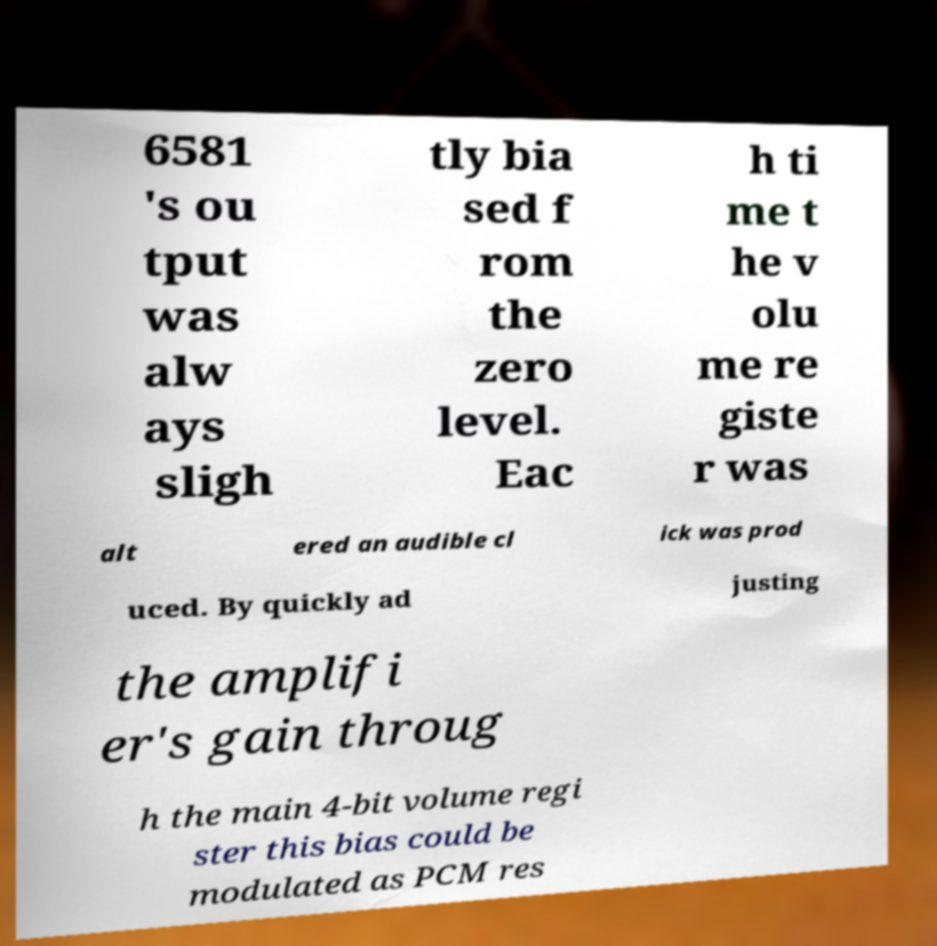I need the written content from this picture converted into text. Can you do that? 6581 's ou tput was alw ays sligh tly bia sed f rom the zero level. Eac h ti me t he v olu me re giste r was alt ered an audible cl ick was prod uced. By quickly ad justing the amplifi er's gain throug h the main 4-bit volume regi ster this bias could be modulated as PCM res 